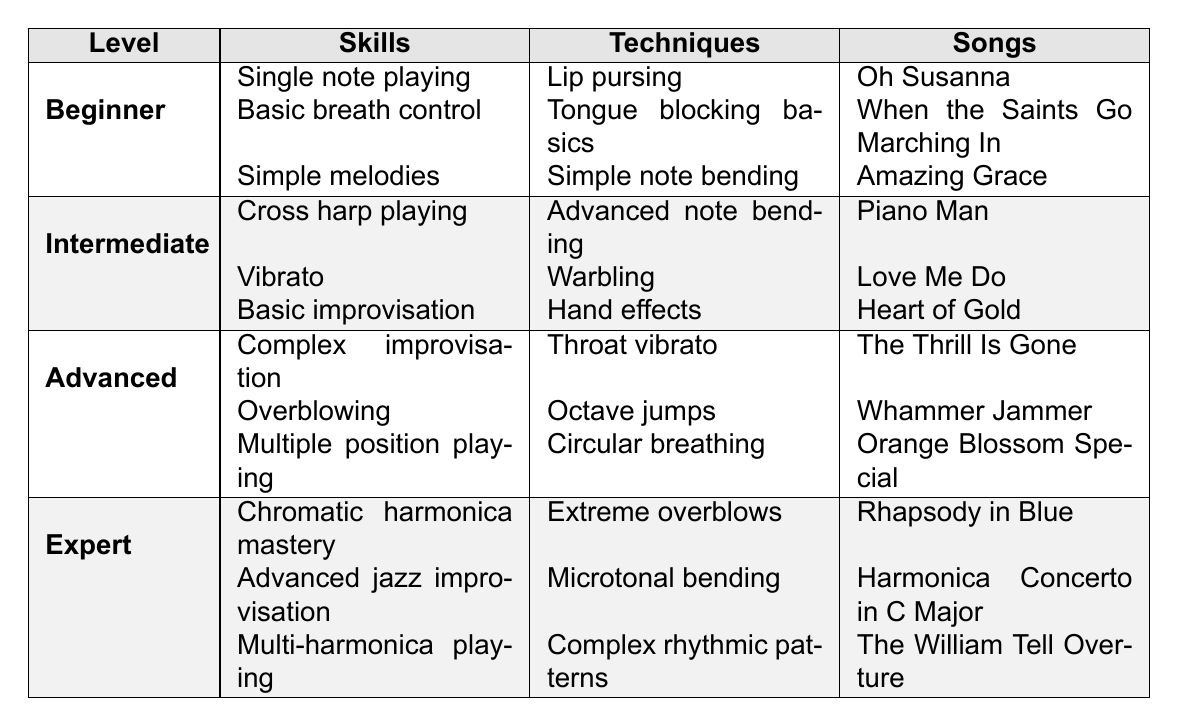What skills are associated with the Advanced level? The Advanced level includes the skills: Complex improvisation, Overblowing, and Multiple position playing. These can be found listed under the Advanced section of the table.
Answer: Complex improvisation, Overblowing, Multiple position playing Which song can a Beginner player play? The Beginner section lists three songs: Oh Susanna, When the Saints Go Marching In, and Amazing Grace. Any of these songs can be played by a Beginner player.
Answer: Oh Susanna, When the Saints Go Marching In, Amazing Grace Is "Throat vibrato" a technique used by Intermediate players? Looking at the table, Throat vibrato is listed under the Advanced techniques, not under Intermediate, so the statement is false.
Answer: No How many techniques are listed for Expert players? The Expert level has three techniques: Extreme overblows, Microtonal bending, and Complex rhythmic patterns. Therefore, the total number is three.
Answer: 3 Which level includes Basic improvisation? The table indicates that Basic improvisation is listed as a skill under the Intermediate level. Therefore, the answer is Intermediate.
Answer: Intermediate What is the difference in the number of songs between Beginner and Expert levels? The Beginner level has three songs, and the Expert level also has three songs. Therefore, the difference in the number of songs is \(3 - 3 = 0\).
Answer: 0 What techniques do Advanced players have that Beginners do not? Advanced players have techniques like Throat vibrato, Octave jumps, and Circular breathing, while Beginners only have Lip pursing, Tongue blocking basics, and Simple note bending. None of the Advanced techniques are listed under Beginners, so they are unique to the Advanced level.
Answer: Throat vibrato, Octave jumps, Circular breathing Can you play "Rhapsody in Blue" at the Intermediate level? "Rhapsody in Blue" is listed as a song under the Expert level in the table, indicating that it is not associated with the Intermediate level.
Answer: No Which is the only level with multi-harmonica playing as a skill? The table shows that Multi-harmonica playing is listed exclusively under the Expert level, making it the only level associated with this skill.
Answer: Expert Are there any songs shared between the Beginner and Intermediate levels? The songs listed under Beginner are: Oh Susanna, When the Saints Go Marching In, and Amazing Grace, while those for Intermediate are Piano Man, Love Me Do, and Heart of Gold. Comparing both lists shows that no songs are shared.
Answer: No What are the skills listed for the Intermediate level? The Intermediate level lists the following skills: Cross harp playing, Vibrato, and Basic improvisation. These can be found under the Intermediate section of the table.
Answer: Cross harp playing, Vibrato, Basic improvisation 